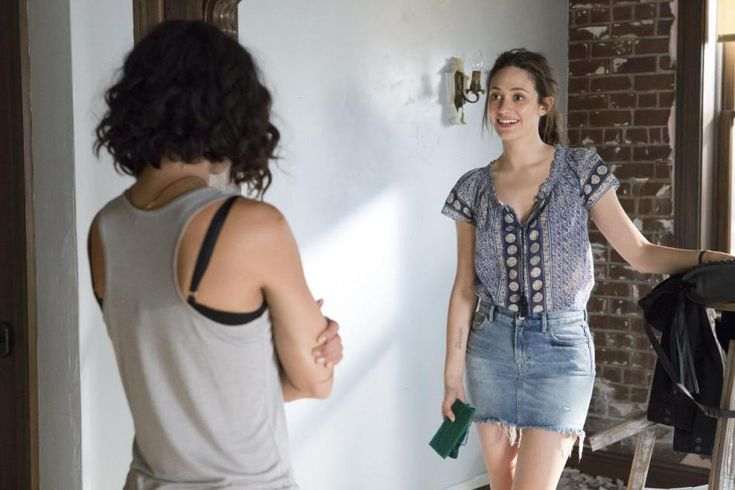Based on the image, what could be the possible relationship between these two women? The image suggests that these two women could be friends or close acquaintances. The relaxed and open posture of the woman facing the camera, combined with her warm smile, indicates a level of comfort and familiarity. They might be catching up on recent events, sharing a light-hearted moment, or possibly discussing a mutual project or interest, given the casual and friendly setting. 